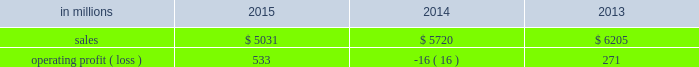Compared with $ 6.2 billion in 2013 .
Operating profits in 2015 were significantly higher than in both 2014 and 2013 .
Excluding facility closure costs , impairment costs and other special items , operating profits in 2015 were 3% ( 3 % ) lower than in 2014 and 4% ( 4 % ) higher than in 2013 .
Benefits from lower input costs ( $ 18 million ) , lower costs associated with the closure of our courtland , alabama mill ( $ 44 million ) and favorable foreign exchange ( $ 33 million ) were offset by lower average sales price realizations and mix ( $ 52 million ) , lower sales volumes ( $ 16 million ) , higher operating costs ( $ 18 million ) and higher planned maintenance downtime costs ( $ 26 million ) .
In addition , operating profits in 2014 include special items costs of $ 554 million associated with the closure of our courtland , alabama mill .
During 2013 , the company accelerated depreciation for certain courtland assets , and evaluated certain other assets for possible alternative uses by one of our other businesses .
The net book value of these assets at december 31 , 2013 was approximately $ 470 million .
In the first quarter of 2014 , we completed our evaluation and concluded that there were no alternative uses for these assets .
We recognized approximately $ 464 million of accelerated depreciation related to these assets in 2014 .
Operating profits in 2014 also include a charge of $ 32 million associated with a foreign tax amnesty program , and a gain of $ 20 million for the resolution of a legal contingency in india , while operating profits in 2013 included costs of $ 118 million associated with the announced closure of our courtland , alabama mill and a $ 123 million impairment charge associated with goodwill and a trade name intangible asset in our india papers business .
Printing papers .
North american printing papers net sales were $ 1.9 billion in 2015 , $ 2.1 billion in 2014 and $ 2.6 billion in 2013 .
Operating profits in 2015 were $ 179 million compared with a loss of $ 398 million ( a gain of $ 156 million excluding costs associated with the shutdown of our courtland , alabama mill ) in 2014 and a gain of $ 36 million ( $ 154 million excluding costs associated with the courtland mill shutdown ) in 2013 .
Sales volumes in 2015 decreased compared with 2014 primarily due to the closure of our courtland mill in 2014 .
Shipments to the domestic market increased , but export shipments declined .
Average sales price realizations decreased , primarily in the domestic market .
Input costs were lower , mainly for energy .
Planned maintenance downtime costs were $ 12 million higher in 2015 .
Operating profits in 2014 were negatively impacted by costs associated with the shutdown of our courtland , alabama mill .
Entering the first quarter of 2016 , sales volumes are expected to be up slightly compared with the fourth quarter of 2015 .
Average sales margins should be about flat reflecting lower average sales price realizations offset by a more favorable product mix .
Input costs are expected to be stable .
Planned maintenance downtime costs are expected to be about $ 14 million lower with an outage scheduled in the 2016 first quarter at our georgetown mill compared with outages at our eastover and riverdale mills in the 2015 fourth quarter .
In january 2015 , the united steelworkers , domtar corporation , packaging corporation of america , finch paper llc and p .
Glatfelter company ( the petitioners ) filed an anti-dumping petition before the united states international trade commission ( itc ) and the united states department of commerce ( doc ) alleging that paper producers in china , indonesia , australia , brazil , and portugal are selling uncoated free sheet paper in sheet form ( the products ) in violation of international trade rules .
The petitioners also filed a countervailing-duties petition with these agencies regarding imports of the products from china and indonesia .
In january 2016 , the doc announced its final countervailing duty rates on imports of the products to the united states from certain producers from china and indonesia .
Also , in january 2016 , the doc announced its final anti-dumping duty rates on imports of the products to the united states from certain producers from australia , brazil , china , indonesia and portugal .
In february 2016 , the itc concluded its anti- dumping and countervailing duties investigations and made a final determination that the u.s .
Market had been injured by imports of the products .
Accordingly , the doc 2019s previously announced countervailing duty rates and anti-dumping duty rates will be in effect for a minimum of five years .
We do not believe the impact of these rates will have a material , adverse effect on our consolidated financial statements .
Brazilian papers net sales for 2015 were $ 878 million compared with $ 1.1 billion in 2014 and $ 1.1 billion in 2013 .
Operating profits for 2015 were $ 186 million compared with $ 177 million ( $ 209 million excluding costs associated with a tax amnesty program ) in 2014 and $ 210 million in 2013 .
Sales volumes in 2015 were lower compared with 2014 reflecting weak economic conditions and the absence of 2014 one-time events .
Average sales price realizations improved for domestic uncoated freesheet paper due to the realization of price increases implemented in the second half of 2015 .
Margins were unfavorably affected by an increased proportion of sales to the lower-margin export markets .
Raw material costs increased for energy and wood .
Operating costs were higher than in 2014 , while planned maintenance downtime costs were $ 4 million lower. .
What percentage of printing paper sales where north american printing papers net sales 2015? 
Computations: ((1.9 * 1000) / 5031)
Answer: 0.37766. 